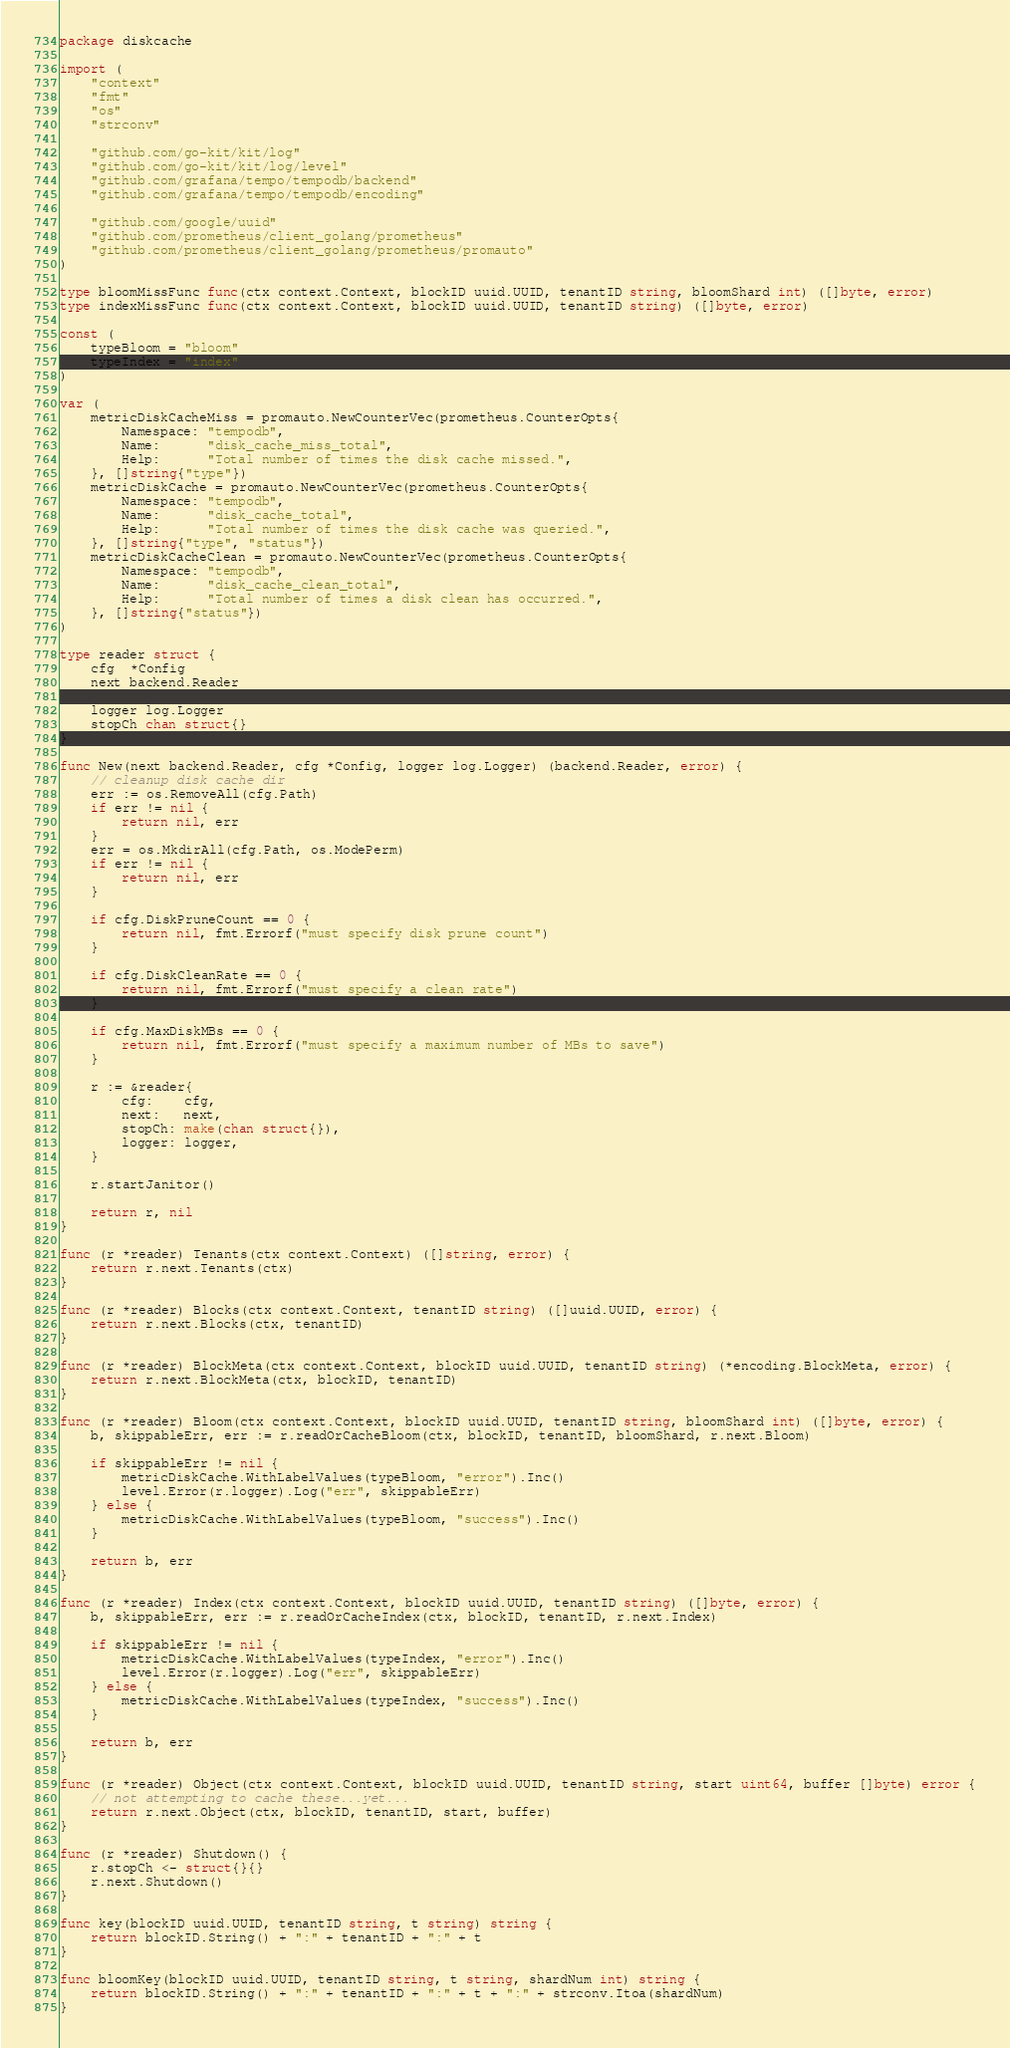Convert code to text. <code><loc_0><loc_0><loc_500><loc_500><_Go_>package diskcache

import (
	"context"
	"fmt"
	"os"
	"strconv"

	"github.com/go-kit/kit/log"
	"github.com/go-kit/kit/log/level"
	"github.com/grafana/tempo/tempodb/backend"
	"github.com/grafana/tempo/tempodb/encoding"

	"github.com/google/uuid"
	"github.com/prometheus/client_golang/prometheus"
	"github.com/prometheus/client_golang/prometheus/promauto"
)

type bloomMissFunc func(ctx context.Context, blockID uuid.UUID, tenantID string, bloomShard int) ([]byte, error)
type indexMissFunc func(ctx context.Context, blockID uuid.UUID, tenantID string) ([]byte, error)

const (
	typeBloom = "bloom"
	typeIndex = "index"
)

var (
	metricDiskCacheMiss = promauto.NewCounterVec(prometheus.CounterOpts{
		Namespace: "tempodb",
		Name:      "disk_cache_miss_total",
		Help:      "Total number of times the disk cache missed.",
	}, []string{"type"})
	metricDiskCache = promauto.NewCounterVec(prometheus.CounterOpts{
		Namespace: "tempodb",
		Name:      "disk_cache_total",
		Help:      "Total number of times the disk cache was queried.",
	}, []string{"type", "status"})
	metricDiskCacheClean = promauto.NewCounterVec(prometheus.CounterOpts{
		Namespace: "tempodb",
		Name:      "disk_cache_clean_total",
		Help:      "Total number of times a disk clean has occurred.",
	}, []string{"status"})
)

type reader struct {
	cfg  *Config
	next backend.Reader

	logger log.Logger
	stopCh chan struct{}
}

func New(next backend.Reader, cfg *Config, logger log.Logger) (backend.Reader, error) {
	// cleanup disk cache dir
	err := os.RemoveAll(cfg.Path)
	if err != nil {
		return nil, err
	}
	err = os.MkdirAll(cfg.Path, os.ModePerm)
	if err != nil {
		return nil, err
	}

	if cfg.DiskPruneCount == 0 {
		return nil, fmt.Errorf("must specify disk prune count")
	}

	if cfg.DiskCleanRate == 0 {
		return nil, fmt.Errorf("must specify a clean rate")
	}

	if cfg.MaxDiskMBs == 0 {
		return nil, fmt.Errorf("must specify a maximum number of MBs to save")
	}

	r := &reader{
		cfg:    cfg,
		next:   next,
		stopCh: make(chan struct{}),
		logger: logger,
	}

	r.startJanitor()

	return r, nil
}

func (r *reader) Tenants(ctx context.Context) ([]string, error) {
	return r.next.Tenants(ctx)
}

func (r *reader) Blocks(ctx context.Context, tenantID string) ([]uuid.UUID, error) {
	return r.next.Blocks(ctx, tenantID)
}

func (r *reader) BlockMeta(ctx context.Context, blockID uuid.UUID, tenantID string) (*encoding.BlockMeta, error) {
	return r.next.BlockMeta(ctx, blockID, tenantID)
}

func (r *reader) Bloom(ctx context.Context, blockID uuid.UUID, tenantID string, bloomShard int) ([]byte, error) {
	b, skippableErr, err := r.readOrCacheBloom(ctx, blockID, tenantID, bloomShard, r.next.Bloom)

	if skippableErr != nil {
		metricDiskCache.WithLabelValues(typeBloom, "error").Inc()
		level.Error(r.logger).Log("err", skippableErr)
	} else {
		metricDiskCache.WithLabelValues(typeBloom, "success").Inc()
	}

	return b, err
}

func (r *reader) Index(ctx context.Context, blockID uuid.UUID, tenantID string) ([]byte, error) {
	b, skippableErr, err := r.readOrCacheIndex(ctx, blockID, tenantID, r.next.Index)

	if skippableErr != nil {
		metricDiskCache.WithLabelValues(typeIndex, "error").Inc()
		level.Error(r.logger).Log("err", skippableErr)
	} else {
		metricDiskCache.WithLabelValues(typeIndex, "success").Inc()
	}

	return b, err
}

func (r *reader) Object(ctx context.Context, blockID uuid.UUID, tenantID string, start uint64, buffer []byte) error {
	// not attempting to cache these...yet...
	return r.next.Object(ctx, blockID, tenantID, start, buffer)
}

func (r *reader) Shutdown() {
	r.stopCh <- struct{}{}
	r.next.Shutdown()
}

func key(blockID uuid.UUID, tenantID string, t string) string {
	return blockID.String() + ":" + tenantID + ":" + t
}

func bloomKey(blockID uuid.UUID, tenantID string, t string, shardNum int) string {
	return blockID.String() + ":" + tenantID + ":" + t + ":" + strconv.Itoa(shardNum)
}
</code> 